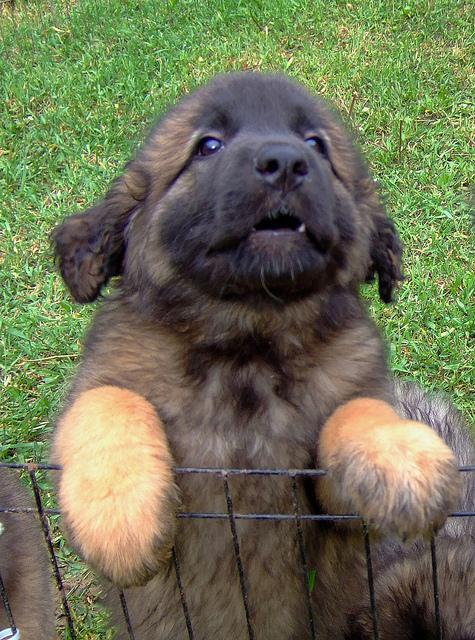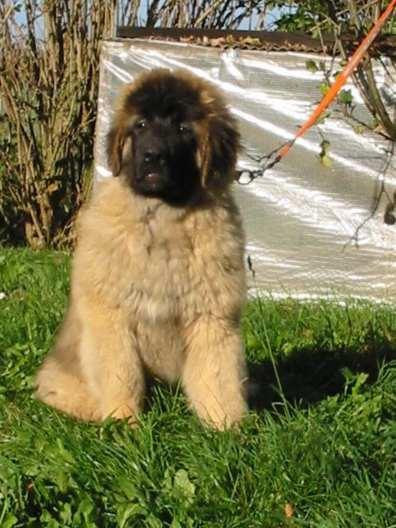The first image is the image on the left, the second image is the image on the right. Given the left and right images, does the statement "There is one dog tongue in the image on the left." hold true? Answer yes or no. No. 